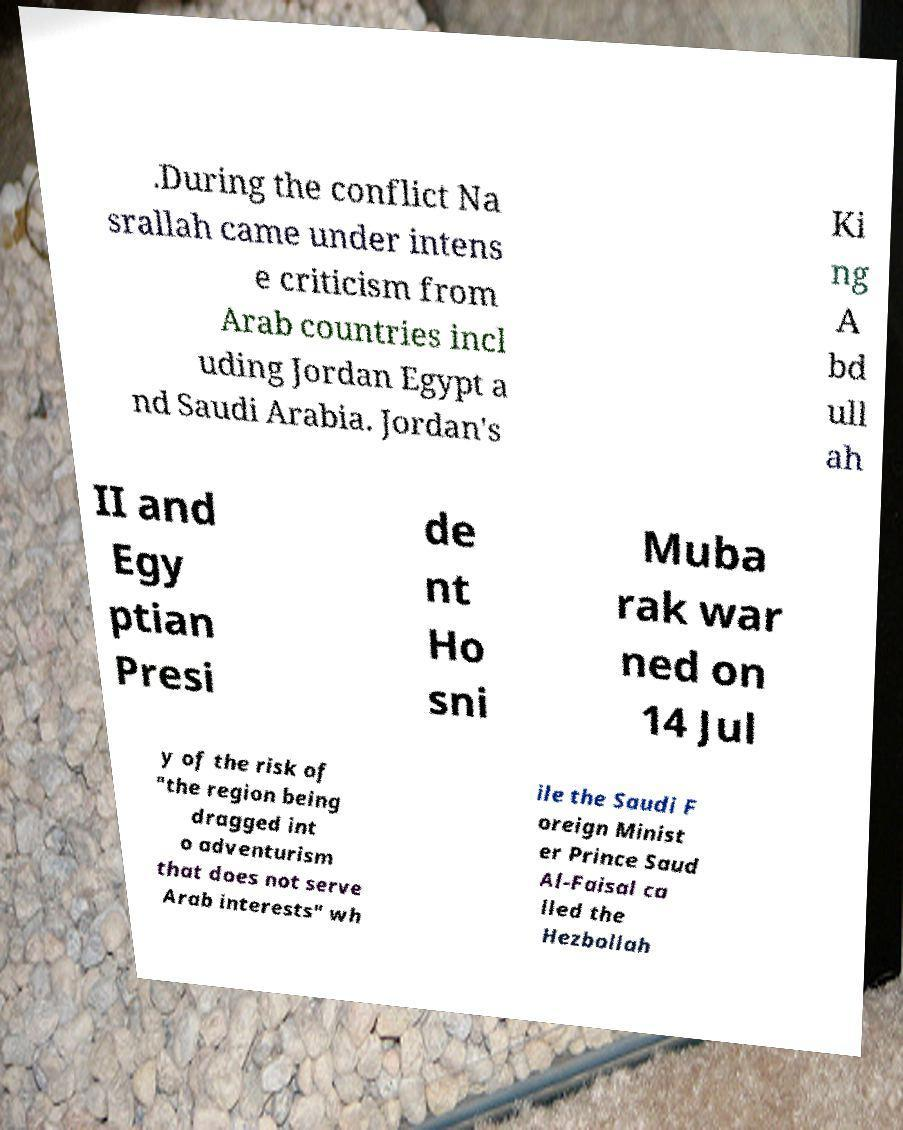For documentation purposes, I need the text within this image transcribed. Could you provide that? .During the conflict Na srallah came under intens e criticism from Arab countries incl uding Jordan Egypt a nd Saudi Arabia. Jordan's Ki ng A bd ull ah II and Egy ptian Presi de nt Ho sni Muba rak war ned on 14 Jul y of the risk of "the region being dragged int o adventurism that does not serve Arab interests" wh ile the Saudi F oreign Minist er Prince Saud Al-Faisal ca lled the Hezbollah 